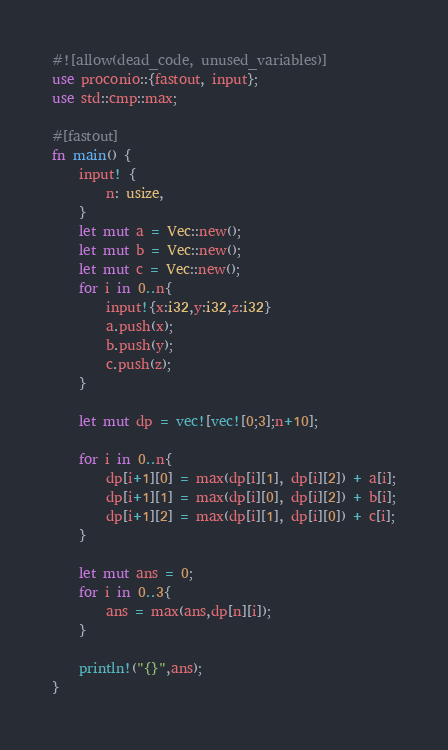<code> <loc_0><loc_0><loc_500><loc_500><_Rust_>#![allow(dead_code, unused_variables)]
use proconio::{fastout, input};
use std::cmp::max;

#[fastout]
fn main() {
    input! {
        n: usize,
    }
    let mut a = Vec::new();
    let mut b = Vec::new();
    let mut c = Vec::new();
    for i in 0..n{
        input!{x:i32,y:i32,z:i32}
        a.push(x);
        b.push(y);
        c.push(z);
    }

    let mut dp = vec![vec![0;3];n+10];
    
    for i in 0..n{
        dp[i+1][0] = max(dp[i][1], dp[i][2]) + a[i];
        dp[i+1][1] = max(dp[i][0], dp[i][2]) + b[i];
        dp[i+1][2] = max(dp[i][1], dp[i][0]) + c[i];
    }

    let mut ans = 0;
    for i in 0..3{
        ans = max(ans,dp[n][i]);
    }
    
    println!("{}",ans);
}
</code> 